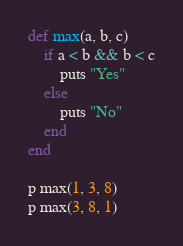<code> <loc_0><loc_0><loc_500><loc_500><_Ruby_>def max(a, b, c)
    if a < b && b < c
        puts "Yes"
    else
        puts "No"
    end
end

p max(1, 3, 8)
p max(3, 8, 1)
</code> 